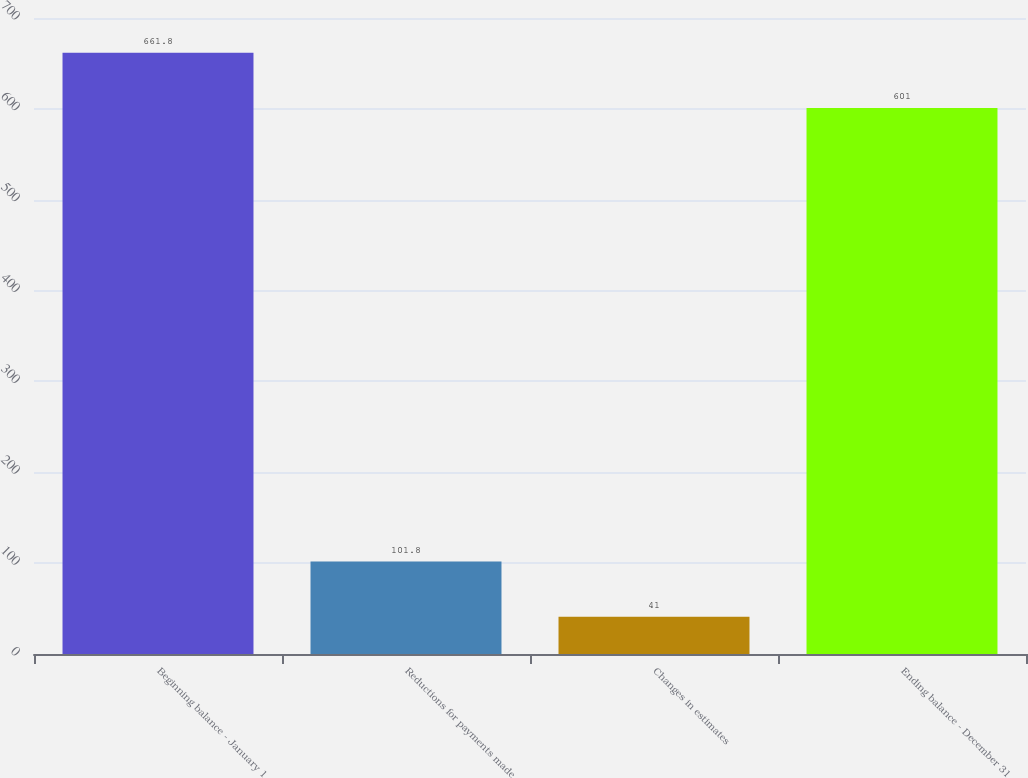<chart> <loc_0><loc_0><loc_500><loc_500><bar_chart><fcel>Beginning balance - January 1<fcel>Reductions for payments made<fcel>Changes in estimates<fcel>Ending balance - December 31<nl><fcel>661.8<fcel>101.8<fcel>41<fcel>601<nl></chart> 